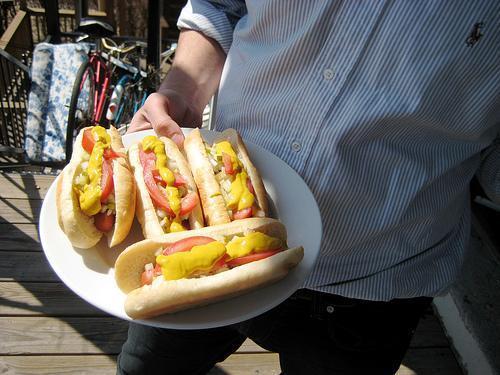How many tomatoes are seen on the hotdogs?
Give a very brief answer. 8. 